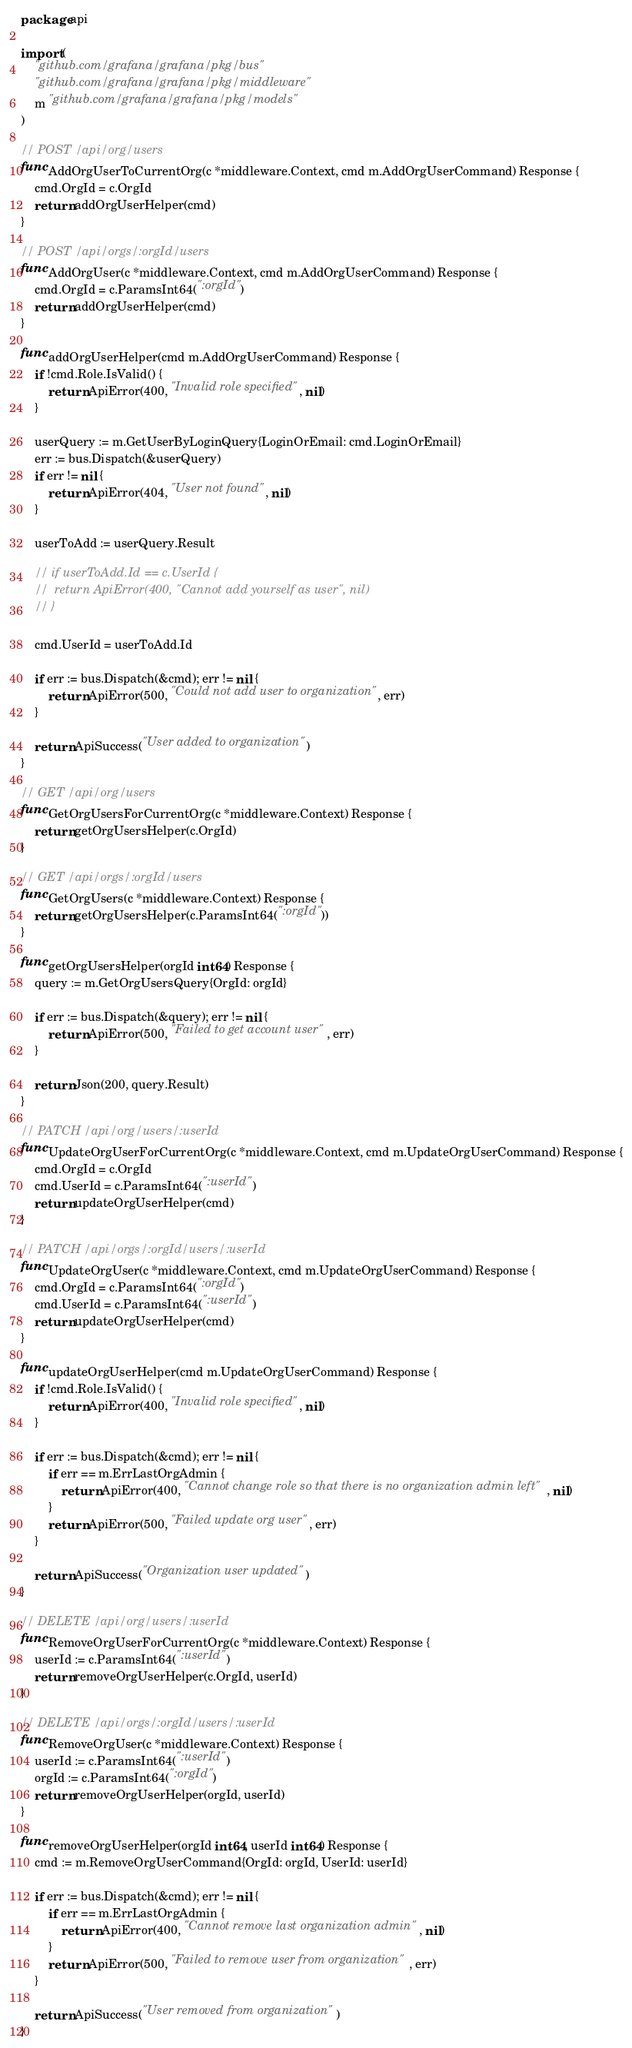<code> <loc_0><loc_0><loc_500><loc_500><_Go_>package api

import (
	"github.com/grafana/grafana/pkg/bus"
	"github.com/grafana/grafana/pkg/middleware"
	m "github.com/grafana/grafana/pkg/models"
)

// POST /api/org/users
func AddOrgUserToCurrentOrg(c *middleware.Context, cmd m.AddOrgUserCommand) Response {
	cmd.OrgId = c.OrgId
	return addOrgUserHelper(cmd)
}

// POST /api/orgs/:orgId/users
func AddOrgUser(c *middleware.Context, cmd m.AddOrgUserCommand) Response {
	cmd.OrgId = c.ParamsInt64(":orgId")
	return addOrgUserHelper(cmd)
}

func addOrgUserHelper(cmd m.AddOrgUserCommand) Response {
	if !cmd.Role.IsValid() {
		return ApiError(400, "Invalid role specified", nil)
	}

	userQuery := m.GetUserByLoginQuery{LoginOrEmail: cmd.LoginOrEmail}
	err := bus.Dispatch(&userQuery)
	if err != nil {
		return ApiError(404, "User not found", nil)
	}

	userToAdd := userQuery.Result

	// if userToAdd.Id == c.UserId {
	// 	return ApiError(400, "Cannot add yourself as user", nil)
	// }

	cmd.UserId = userToAdd.Id

	if err := bus.Dispatch(&cmd); err != nil {
		return ApiError(500, "Could not add user to organization", err)
	}

	return ApiSuccess("User added to organization")
}

// GET /api/org/users
func GetOrgUsersForCurrentOrg(c *middleware.Context) Response {
	return getOrgUsersHelper(c.OrgId)
}

// GET /api/orgs/:orgId/users
func GetOrgUsers(c *middleware.Context) Response {
	return getOrgUsersHelper(c.ParamsInt64(":orgId"))
}

func getOrgUsersHelper(orgId int64) Response {
	query := m.GetOrgUsersQuery{OrgId: orgId}

	if err := bus.Dispatch(&query); err != nil {
		return ApiError(500, "Failed to get account user", err)
	}

	return Json(200, query.Result)
}

// PATCH /api/org/users/:userId
func UpdateOrgUserForCurrentOrg(c *middleware.Context, cmd m.UpdateOrgUserCommand) Response {
	cmd.OrgId = c.OrgId
	cmd.UserId = c.ParamsInt64(":userId")
	return updateOrgUserHelper(cmd)
}

// PATCH /api/orgs/:orgId/users/:userId
func UpdateOrgUser(c *middleware.Context, cmd m.UpdateOrgUserCommand) Response {
	cmd.OrgId = c.ParamsInt64(":orgId")
	cmd.UserId = c.ParamsInt64(":userId")
	return updateOrgUserHelper(cmd)
}

func updateOrgUserHelper(cmd m.UpdateOrgUserCommand) Response {
	if !cmd.Role.IsValid() {
		return ApiError(400, "Invalid role specified", nil)
	}

	if err := bus.Dispatch(&cmd); err != nil {
		if err == m.ErrLastOrgAdmin {
			return ApiError(400, "Cannot change role so that there is no organization admin left", nil)
		}
		return ApiError(500, "Failed update org user", err)
	}

	return ApiSuccess("Organization user updated")
}

// DELETE /api/org/users/:userId
func RemoveOrgUserForCurrentOrg(c *middleware.Context) Response {
	userId := c.ParamsInt64(":userId")
	return removeOrgUserHelper(c.OrgId, userId)
}

// DELETE /api/orgs/:orgId/users/:userId
func RemoveOrgUser(c *middleware.Context) Response {
	userId := c.ParamsInt64(":userId")
	orgId := c.ParamsInt64(":orgId")
	return removeOrgUserHelper(orgId, userId)
}

func removeOrgUserHelper(orgId int64, userId int64) Response {
	cmd := m.RemoveOrgUserCommand{OrgId: orgId, UserId: userId}

	if err := bus.Dispatch(&cmd); err != nil {
		if err == m.ErrLastOrgAdmin {
			return ApiError(400, "Cannot remove last organization admin", nil)
		}
		return ApiError(500, "Failed to remove user from organization", err)
	}

	return ApiSuccess("User removed from organization")
}
</code> 